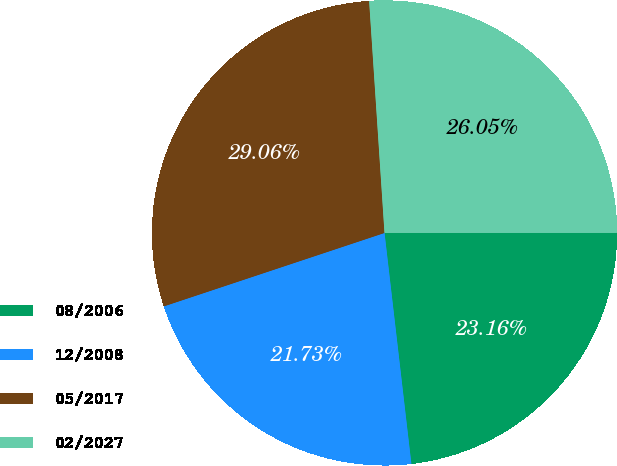Convert chart to OTSL. <chart><loc_0><loc_0><loc_500><loc_500><pie_chart><fcel>08/2006<fcel>12/2008<fcel>05/2017<fcel>02/2027<nl><fcel>23.16%<fcel>21.73%<fcel>29.06%<fcel>26.05%<nl></chart> 